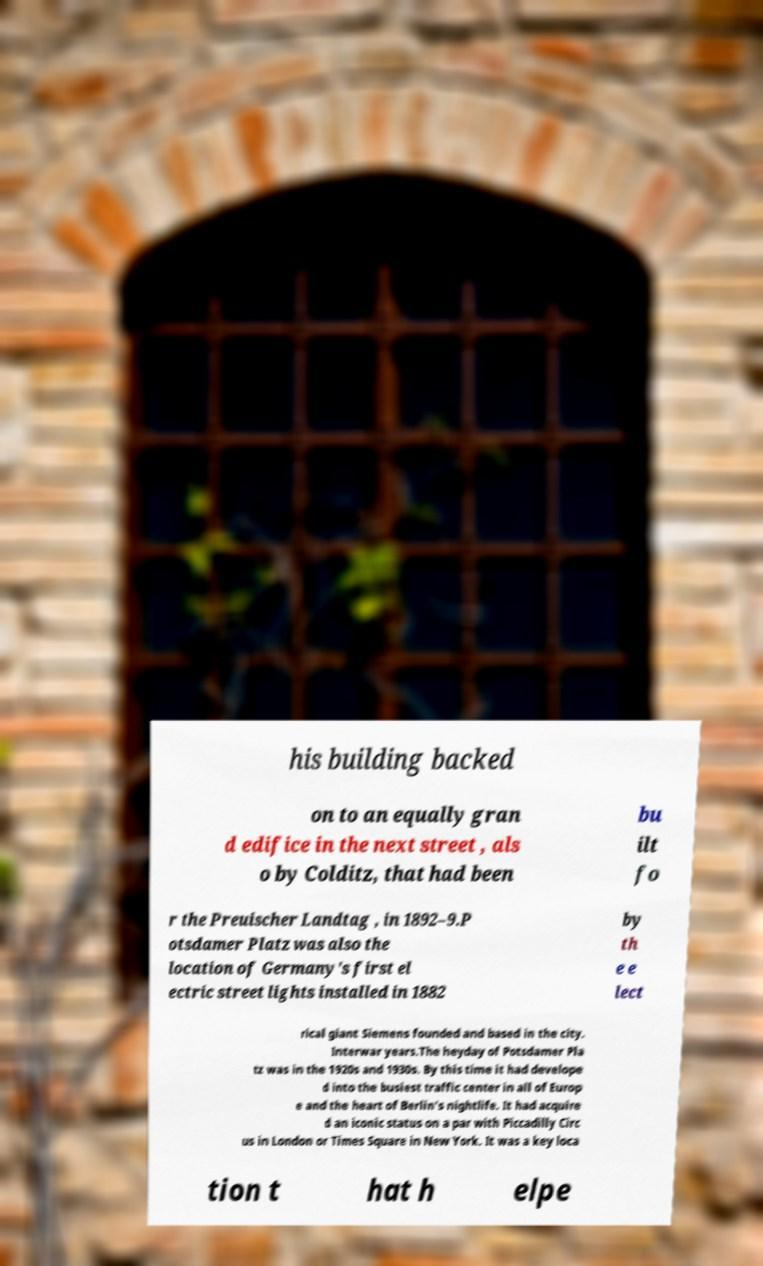Can you read and provide the text displayed in the image?This photo seems to have some interesting text. Can you extract and type it out for me? his building backed on to an equally gran d edifice in the next street , als o by Colditz, that had been bu ilt fo r the Preuischer Landtag , in 1892–9.P otsdamer Platz was also the location of Germany's first el ectric street lights installed in 1882 by th e e lect rical giant Siemens founded and based in the city. Interwar years.The heyday of Potsdamer Pla tz was in the 1920s and 1930s. By this time it had develope d into the busiest traffic center in all of Europ e and the heart of Berlin's nightlife. It had acquire d an iconic status on a par with Piccadilly Circ us in London or Times Square in New York. It was a key loca tion t hat h elpe 